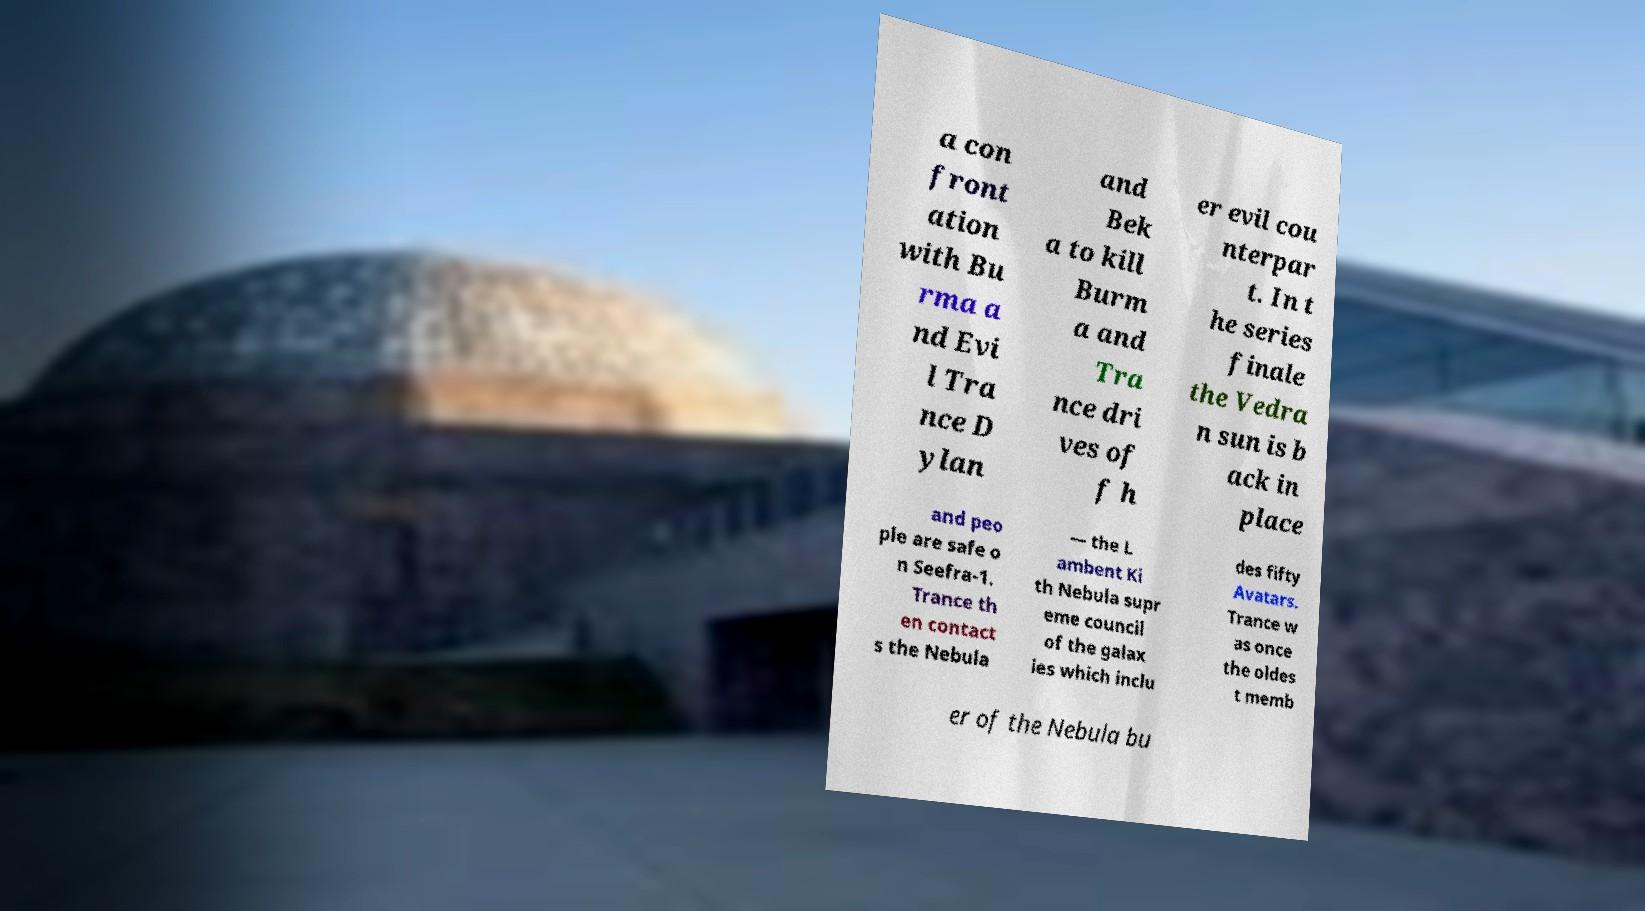Can you read and provide the text displayed in the image?This photo seems to have some interesting text. Can you extract and type it out for me? a con front ation with Bu rma a nd Evi l Tra nce D ylan and Bek a to kill Burm a and Tra nce dri ves of f h er evil cou nterpar t. In t he series finale the Vedra n sun is b ack in place and peo ple are safe o n Seefra-1. Trance th en contact s the Nebula — the L ambent Ki th Nebula supr eme council of the galax ies which inclu des fifty Avatars. Trance w as once the oldes t memb er of the Nebula bu 